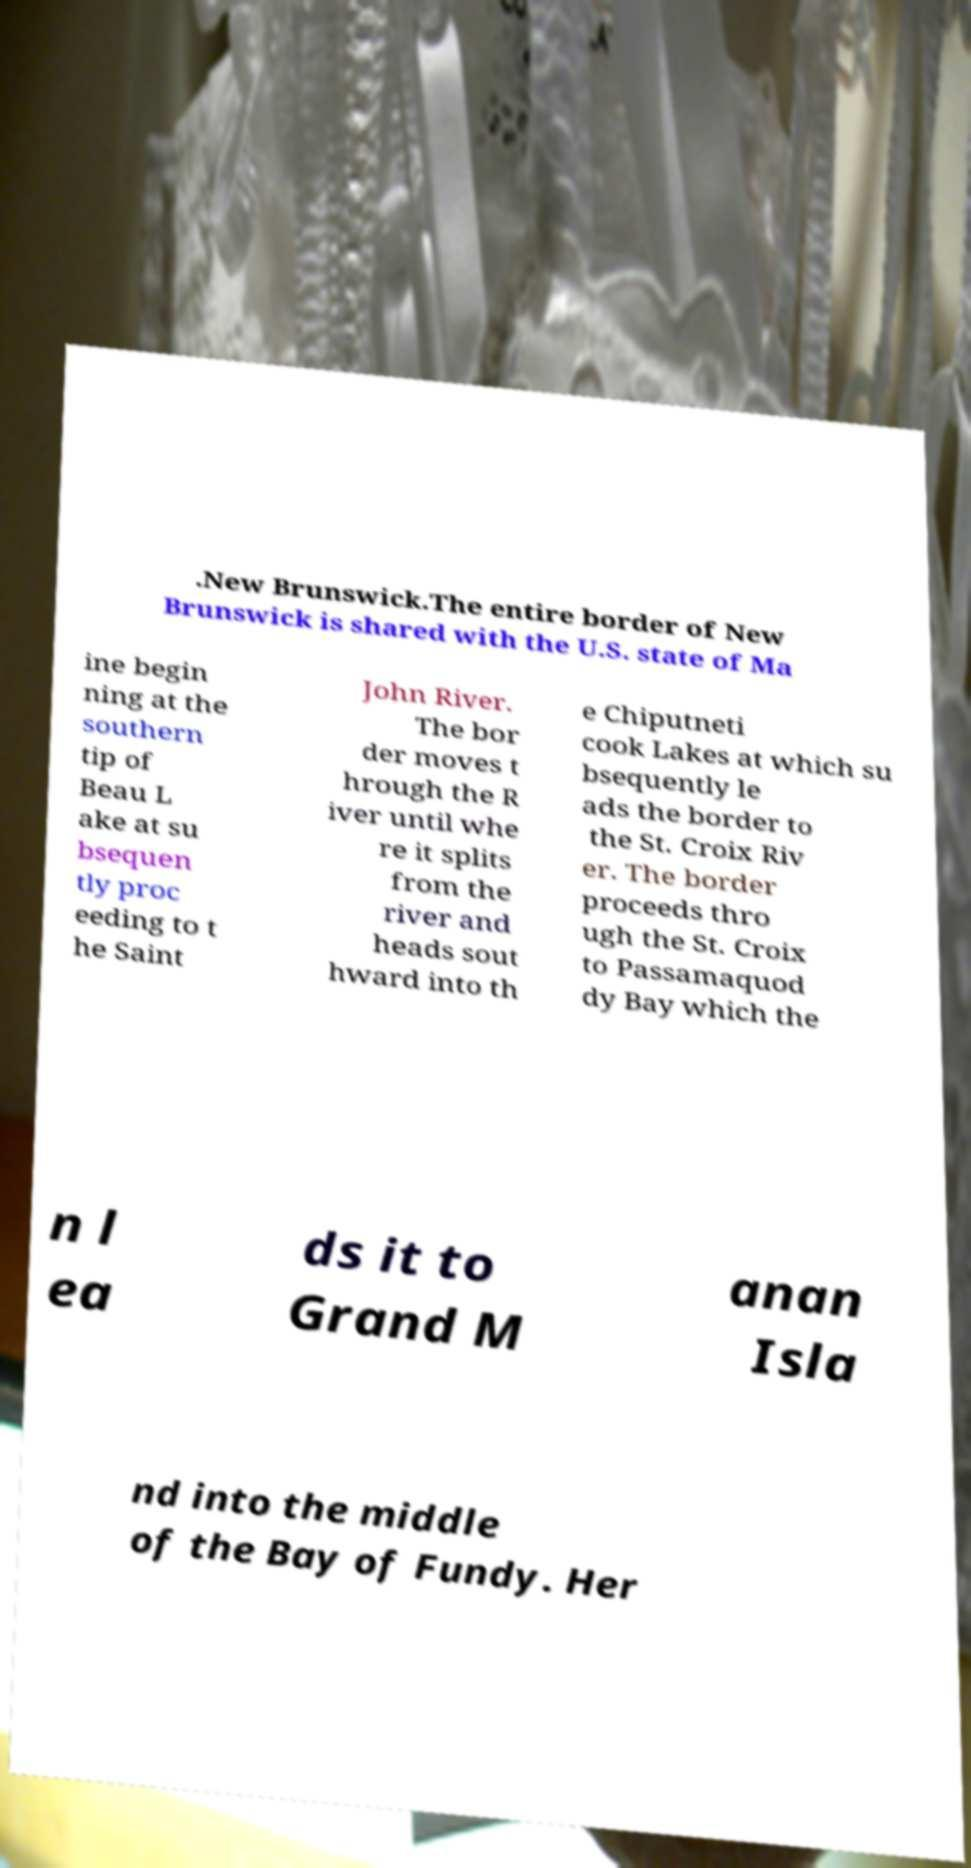Could you extract and type out the text from this image? .New Brunswick.The entire border of New Brunswick is shared with the U.S. state of Ma ine begin ning at the southern tip of Beau L ake at su bsequen tly proc eeding to t he Saint John River. The bor der moves t hrough the R iver until whe re it splits from the river and heads sout hward into th e Chiputneti cook Lakes at which su bsequently le ads the border to the St. Croix Riv er. The border proceeds thro ugh the St. Croix to Passamaquod dy Bay which the n l ea ds it to Grand M anan Isla nd into the middle of the Bay of Fundy. Her 